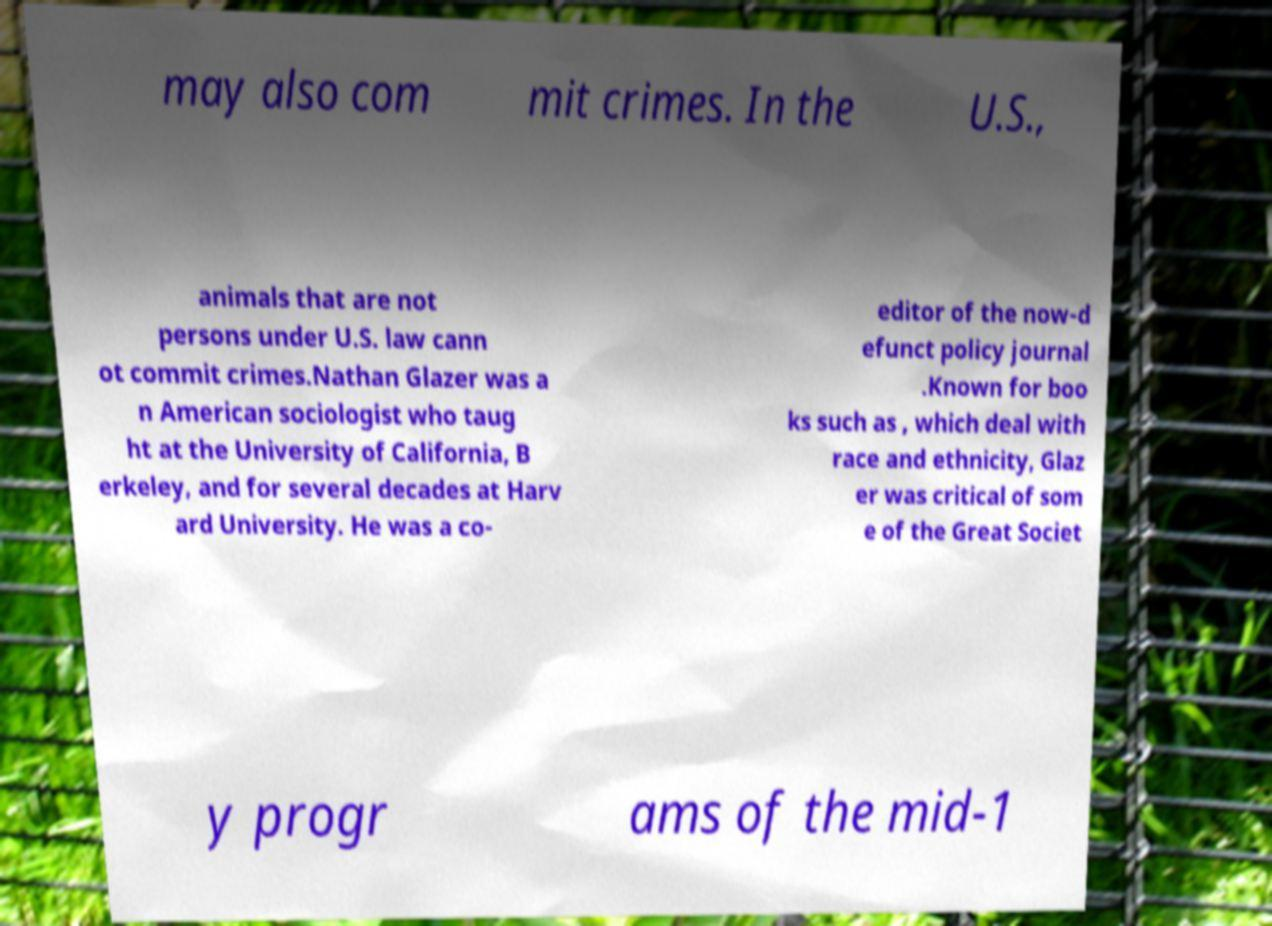Could you extract and type out the text from this image? may also com mit crimes. In the U.S., animals that are not persons under U.S. law cann ot commit crimes.Nathan Glazer was a n American sociologist who taug ht at the University of California, B erkeley, and for several decades at Harv ard University. He was a co- editor of the now-d efunct policy journal .Known for boo ks such as , which deal with race and ethnicity, Glaz er was critical of som e of the Great Societ y progr ams of the mid-1 